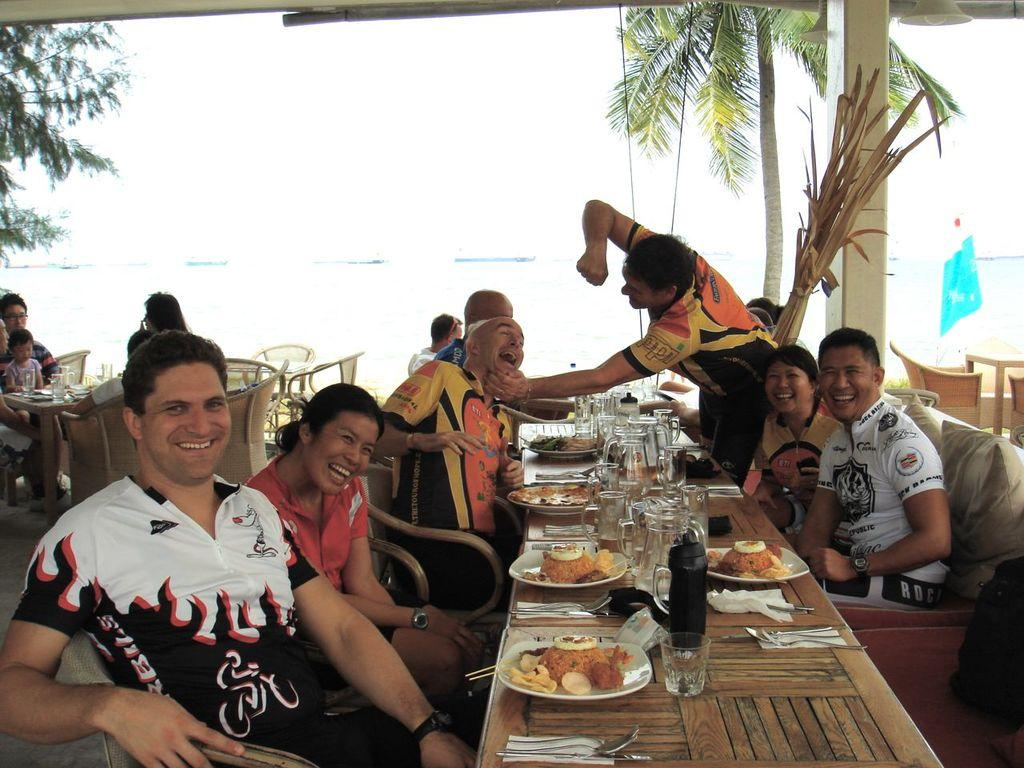How many people are in the image? There is a group of persons in the image. What are the persons in the image doing? The persons are sitting and having their food. What can be seen in the background of the image? There are trees and an ocean in the background of the image. Can you see a crown on any of the persons in the image? There is no crown visible on any of the persons in the image. How many children are present in the image? The provided facts do not mention the age of the persons in the image, so it is impossible to determine if there are any children present. 